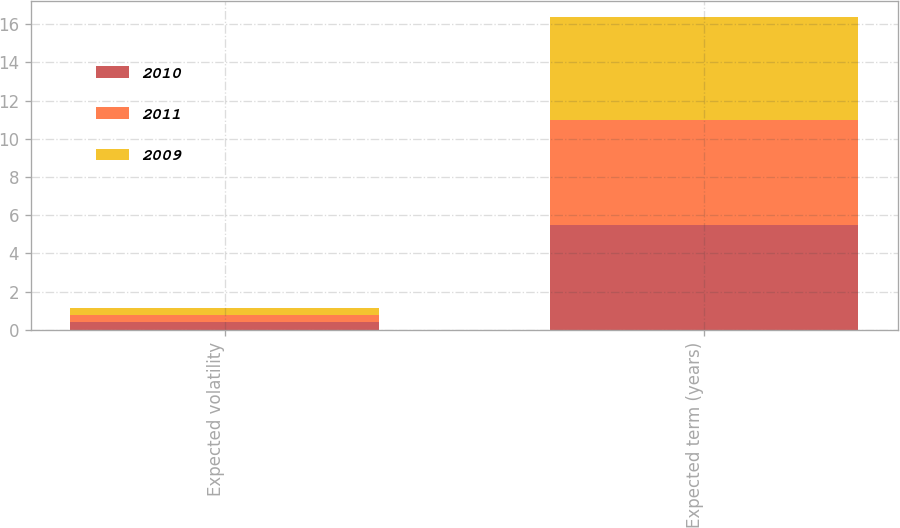Convert chart. <chart><loc_0><loc_0><loc_500><loc_500><stacked_bar_chart><ecel><fcel>Expected volatility<fcel>Expected term (years)<nl><fcel>2010<fcel>0.39<fcel>5.5<nl><fcel>2011<fcel>0.41<fcel>5.5<nl><fcel>2009<fcel>0.35<fcel>5.4<nl></chart> 